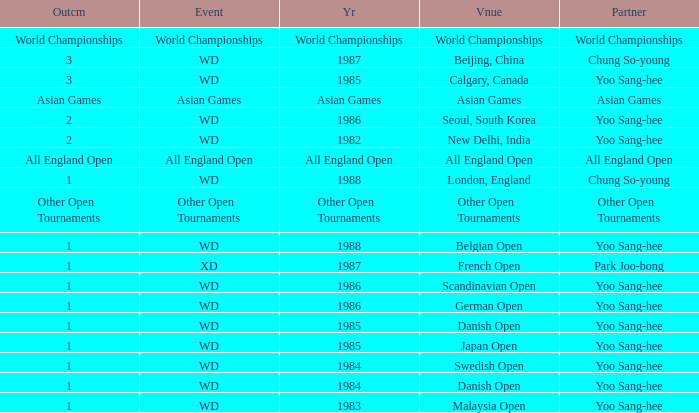What is the companion during the asian games year? Asian Games. 